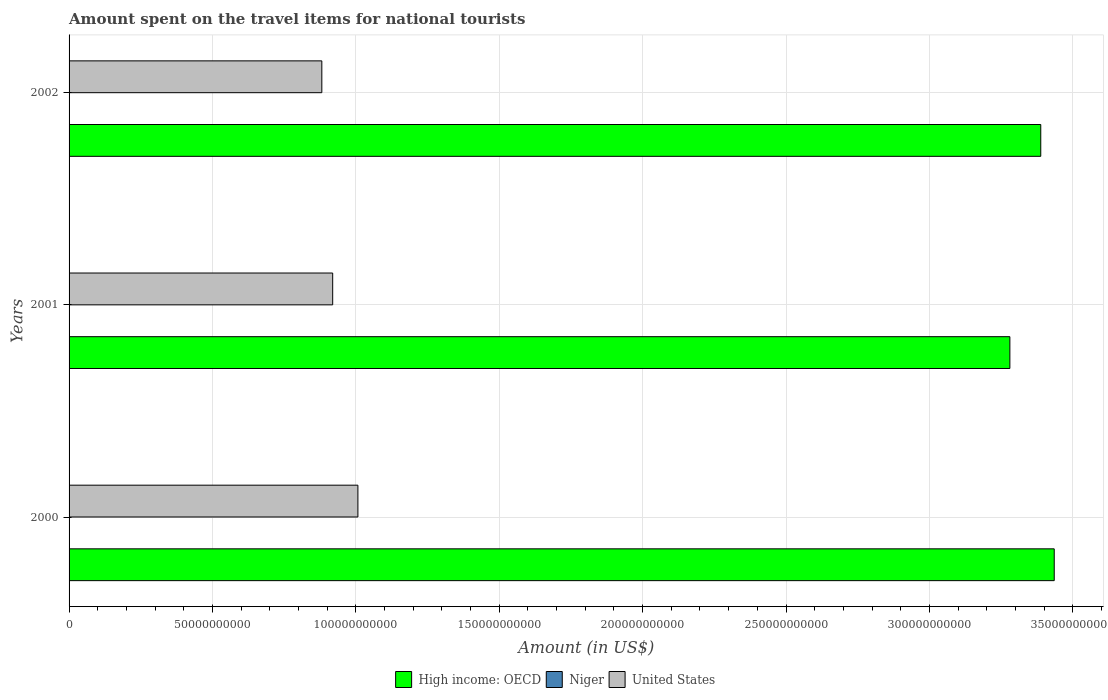How many different coloured bars are there?
Provide a short and direct response. 3. How many groups of bars are there?
Give a very brief answer. 3. What is the label of the 1st group of bars from the top?
Ensure brevity in your answer.  2002. In how many cases, is the number of bars for a given year not equal to the number of legend labels?
Your answer should be compact. 0. What is the amount spent on the travel items for national tourists in United States in 2002?
Ensure brevity in your answer.  8.81e+1. Across all years, what is the maximum amount spent on the travel items for national tourists in United States?
Provide a short and direct response. 1.01e+11. Across all years, what is the minimum amount spent on the travel items for national tourists in Niger?
Provide a short and direct response. 2.00e+07. In which year was the amount spent on the travel items for national tourists in Niger minimum?
Offer a terse response. 2002. What is the total amount spent on the travel items for national tourists in Niger in the graph?
Make the answer very short. 7.30e+07. What is the difference between the amount spent on the travel items for national tourists in United States in 2000 and that in 2002?
Keep it short and to the point. 1.26e+1. What is the difference between the amount spent on the travel items for national tourists in United States in 2000 and the amount spent on the travel items for national tourists in High income: OECD in 2001?
Your answer should be compact. -2.27e+11. What is the average amount spent on the travel items for national tourists in High income: OECD per year?
Your answer should be very brief. 3.37e+11. In the year 2000, what is the difference between the amount spent on the travel items for national tourists in Niger and amount spent on the travel items for national tourists in United States?
Keep it short and to the point. -1.01e+11. In how many years, is the amount spent on the travel items for national tourists in High income: OECD greater than 190000000000 US$?
Your answer should be very brief. 3. What is the ratio of the amount spent on the travel items for national tourists in United States in 2000 to that in 2002?
Provide a succinct answer. 1.14. Is the difference between the amount spent on the travel items for national tourists in Niger in 2001 and 2002 greater than the difference between the amount spent on the travel items for national tourists in United States in 2001 and 2002?
Offer a terse response. No. What is the difference between the highest and the second highest amount spent on the travel items for national tourists in Niger?
Provide a succinct answer. 7.00e+06. What is the difference between the highest and the lowest amount spent on the travel items for national tourists in Niger?
Your answer should be compact. 1.00e+07. Is the sum of the amount spent on the travel items for national tourists in United States in 2000 and 2002 greater than the maximum amount spent on the travel items for national tourists in High income: OECD across all years?
Make the answer very short. No. Is it the case that in every year, the sum of the amount spent on the travel items for national tourists in United States and amount spent on the travel items for national tourists in Niger is greater than the amount spent on the travel items for national tourists in High income: OECD?
Your answer should be compact. No. How many bars are there?
Provide a succinct answer. 9. Are all the bars in the graph horizontal?
Make the answer very short. Yes. What is the difference between two consecutive major ticks on the X-axis?
Keep it short and to the point. 5.00e+1. Are the values on the major ticks of X-axis written in scientific E-notation?
Your answer should be very brief. No. Does the graph contain any zero values?
Provide a short and direct response. No. Where does the legend appear in the graph?
Your response must be concise. Bottom center. How many legend labels are there?
Ensure brevity in your answer.  3. What is the title of the graph?
Give a very brief answer. Amount spent on the travel items for national tourists. What is the label or title of the Y-axis?
Your response must be concise. Years. What is the Amount (in US$) in High income: OECD in 2000?
Provide a short and direct response. 3.44e+11. What is the Amount (in US$) of Niger in 2000?
Your response must be concise. 2.30e+07. What is the Amount (in US$) of United States in 2000?
Make the answer very short. 1.01e+11. What is the Amount (in US$) in High income: OECD in 2001?
Provide a short and direct response. 3.28e+11. What is the Amount (in US$) in Niger in 2001?
Offer a very short reply. 3.00e+07. What is the Amount (in US$) of United States in 2001?
Offer a very short reply. 9.19e+1. What is the Amount (in US$) of High income: OECD in 2002?
Provide a succinct answer. 3.39e+11. What is the Amount (in US$) of United States in 2002?
Your answer should be very brief. 8.81e+1. Across all years, what is the maximum Amount (in US$) of High income: OECD?
Make the answer very short. 3.44e+11. Across all years, what is the maximum Amount (in US$) of Niger?
Your answer should be very brief. 3.00e+07. Across all years, what is the maximum Amount (in US$) in United States?
Give a very brief answer. 1.01e+11. Across all years, what is the minimum Amount (in US$) in High income: OECD?
Keep it short and to the point. 3.28e+11. Across all years, what is the minimum Amount (in US$) of Niger?
Your answer should be compact. 2.00e+07. Across all years, what is the minimum Amount (in US$) of United States?
Give a very brief answer. 8.81e+1. What is the total Amount (in US$) in High income: OECD in the graph?
Keep it short and to the point. 1.01e+12. What is the total Amount (in US$) of Niger in the graph?
Provide a succinct answer. 7.30e+07. What is the total Amount (in US$) in United States in the graph?
Offer a very short reply. 2.81e+11. What is the difference between the Amount (in US$) of High income: OECD in 2000 and that in 2001?
Make the answer very short. 1.55e+1. What is the difference between the Amount (in US$) of Niger in 2000 and that in 2001?
Keep it short and to the point. -7.00e+06. What is the difference between the Amount (in US$) of United States in 2000 and that in 2001?
Give a very brief answer. 8.79e+09. What is the difference between the Amount (in US$) of High income: OECD in 2000 and that in 2002?
Offer a very short reply. 4.70e+09. What is the difference between the Amount (in US$) of United States in 2000 and that in 2002?
Offer a terse response. 1.26e+1. What is the difference between the Amount (in US$) in High income: OECD in 2001 and that in 2002?
Offer a very short reply. -1.08e+1. What is the difference between the Amount (in US$) in Niger in 2001 and that in 2002?
Provide a succinct answer. 1.00e+07. What is the difference between the Amount (in US$) in United States in 2001 and that in 2002?
Offer a terse response. 3.79e+09. What is the difference between the Amount (in US$) in High income: OECD in 2000 and the Amount (in US$) in Niger in 2001?
Offer a very short reply. 3.44e+11. What is the difference between the Amount (in US$) in High income: OECD in 2000 and the Amount (in US$) in United States in 2001?
Provide a succinct answer. 2.52e+11. What is the difference between the Amount (in US$) in Niger in 2000 and the Amount (in US$) in United States in 2001?
Give a very brief answer. -9.19e+1. What is the difference between the Amount (in US$) in High income: OECD in 2000 and the Amount (in US$) in Niger in 2002?
Give a very brief answer. 3.44e+11. What is the difference between the Amount (in US$) of High income: OECD in 2000 and the Amount (in US$) of United States in 2002?
Provide a short and direct response. 2.55e+11. What is the difference between the Amount (in US$) of Niger in 2000 and the Amount (in US$) of United States in 2002?
Offer a very short reply. -8.81e+1. What is the difference between the Amount (in US$) in High income: OECD in 2001 and the Amount (in US$) in Niger in 2002?
Your response must be concise. 3.28e+11. What is the difference between the Amount (in US$) of High income: OECD in 2001 and the Amount (in US$) of United States in 2002?
Make the answer very short. 2.40e+11. What is the difference between the Amount (in US$) in Niger in 2001 and the Amount (in US$) in United States in 2002?
Offer a very short reply. -8.81e+1. What is the average Amount (in US$) of High income: OECD per year?
Your answer should be very brief. 3.37e+11. What is the average Amount (in US$) in Niger per year?
Offer a very short reply. 2.43e+07. What is the average Amount (in US$) of United States per year?
Provide a succinct answer. 9.36e+1. In the year 2000, what is the difference between the Amount (in US$) in High income: OECD and Amount (in US$) in Niger?
Ensure brevity in your answer.  3.44e+11. In the year 2000, what is the difference between the Amount (in US$) of High income: OECD and Amount (in US$) of United States?
Provide a short and direct response. 2.43e+11. In the year 2000, what is the difference between the Amount (in US$) in Niger and Amount (in US$) in United States?
Provide a succinct answer. -1.01e+11. In the year 2001, what is the difference between the Amount (in US$) of High income: OECD and Amount (in US$) of Niger?
Ensure brevity in your answer.  3.28e+11. In the year 2001, what is the difference between the Amount (in US$) of High income: OECD and Amount (in US$) of United States?
Your answer should be compact. 2.36e+11. In the year 2001, what is the difference between the Amount (in US$) in Niger and Amount (in US$) in United States?
Offer a terse response. -9.19e+1. In the year 2002, what is the difference between the Amount (in US$) of High income: OECD and Amount (in US$) of Niger?
Offer a very short reply. 3.39e+11. In the year 2002, what is the difference between the Amount (in US$) in High income: OECD and Amount (in US$) in United States?
Keep it short and to the point. 2.51e+11. In the year 2002, what is the difference between the Amount (in US$) in Niger and Amount (in US$) in United States?
Make the answer very short. -8.81e+1. What is the ratio of the Amount (in US$) in High income: OECD in 2000 to that in 2001?
Your answer should be compact. 1.05. What is the ratio of the Amount (in US$) in Niger in 2000 to that in 2001?
Give a very brief answer. 0.77. What is the ratio of the Amount (in US$) in United States in 2000 to that in 2001?
Provide a short and direct response. 1.1. What is the ratio of the Amount (in US$) in High income: OECD in 2000 to that in 2002?
Your response must be concise. 1.01. What is the ratio of the Amount (in US$) in Niger in 2000 to that in 2002?
Make the answer very short. 1.15. What is the ratio of the Amount (in US$) of United States in 2000 to that in 2002?
Give a very brief answer. 1.14. What is the ratio of the Amount (in US$) of High income: OECD in 2001 to that in 2002?
Your answer should be very brief. 0.97. What is the ratio of the Amount (in US$) in United States in 2001 to that in 2002?
Your response must be concise. 1.04. What is the difference between the highest and the second highest Amount (in US$) of High income: OECD?
Your response must be concise. 4.70e+09. What is the difference between the highest and the second highest Amount (in US$) in United States?
Ensure brevity in your answer.  8.79e+09. What is the difference between the highest and the lowest Amount (in US$) in High income: OECD?
Your answer should be compact. 1.55e+1. What is the difference between the highest and the lowest Amount (in US$) of United States?
Keep it short and to the point. 1.26e+1. 